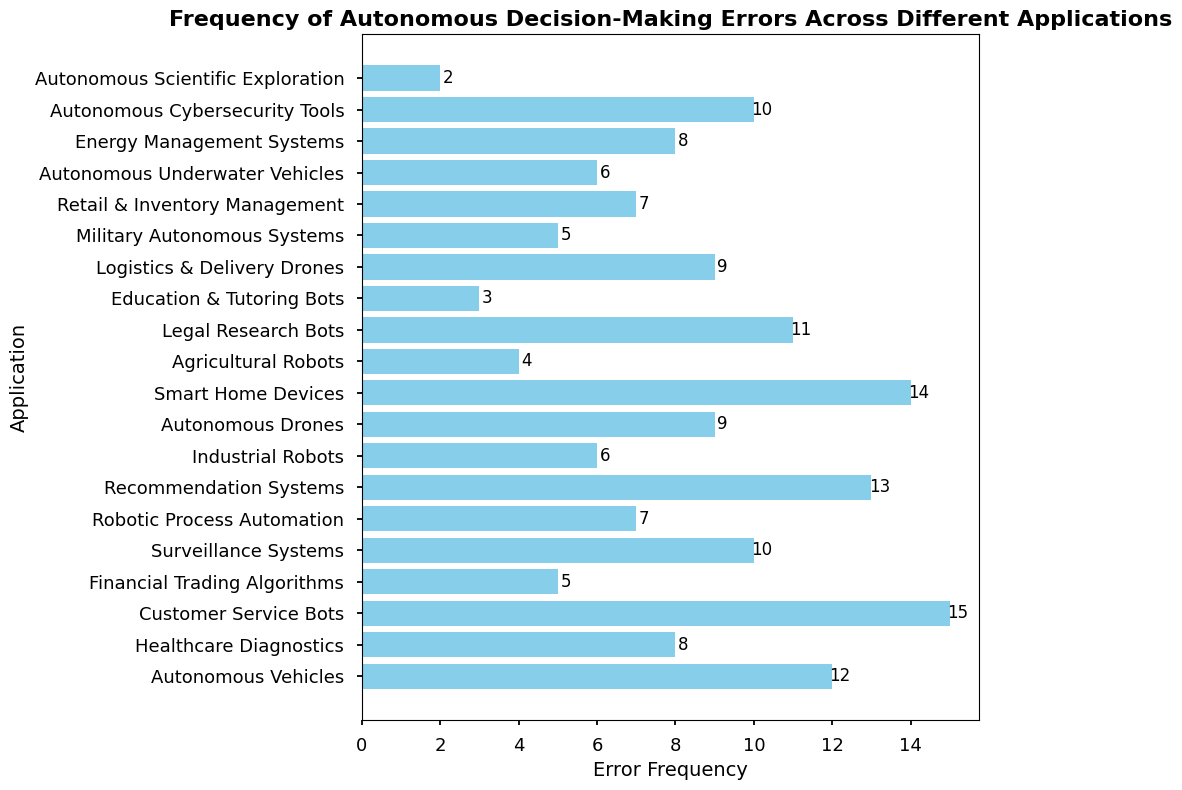How many applications have an error frequency greater than 10? Count the number of applications where the error frequency value exceeds 10. From the bar chart, these applications are "Customer Service Bots", "Recommendation Systems", "Smart Home Devices", and "Legal Research Bots".
Answer: 4 What's the difference in error frequency between the application with the highest errors and the one with the lowest? Identify the applications with the highest error frequency ("Customer Service Bots" with 15 errors) and the lowest error frequency ("Autonomous Scientific Exploration" with 2 errors). Subtract the lowest from the highest error frequency (15 - 2).
Answer: 13 Which application has an error frequency closest to the average error frequency across all applications? Calculate the average error frequency by summing all error frequencies and dividing by the number of applications. Compare each application's error frequency to find the closest one. The error frequencies are (12, 8, 15, 5, 10, 7, 13, 6, 9, 14, 4, 11, 3, 9, 5, 7, 6, 8, 10, 2). The sum is 164 and the average is 164 / 20 = 8.2. "Healthcare Diagnostics" and "Energy Management Systems" both have an error frequency of 8, which is closest to the average.
Answer: Healthcare Diagnostics and Energy Management Systems Between "Healthcare Diagnostics" and "Autonomous Drones," which one has a higher error frequency, and by how much? Compare their error frequencies, "Healthcare Diagnostics" has 8 and "Autonomous Drones" has 9. Calculate the difference (9 - 8).
Answer: Autonomous Drones by 1 What is the cumulative error frequency of all applications related to autonomous vehicles and drones? Sum the error frequencies of "Autonomous Vehicles" (12), "Autonomous Drones" (9), "Logistics & Delivery Drones" (9), "Military Autonomous Systems" (5), and "Autonomous Underwater Vehicles" (6). 12 + 9 + 9 + 5 + 6 = 41
Answer: 41 Which application has the second-lowest error frequency? Identify the lowest error frequency first, which is "Autonomous Scientific Exploration" with 2 errors. The second-lowest is then "Education & Tutoring Bots" with 3 errors.
Answer: Education & Tutoring Bots Are there any applications with an error frequency of exactly 10? If so, name them. Check the bar chart to see if any bars reach the 10 mark. "Surveillance Systems" and "Autonomous Cybersecurity Tools" both have an error frequency of 10.
Answer: Surveillance Systems and Autonomous Cybersecurity Tools 